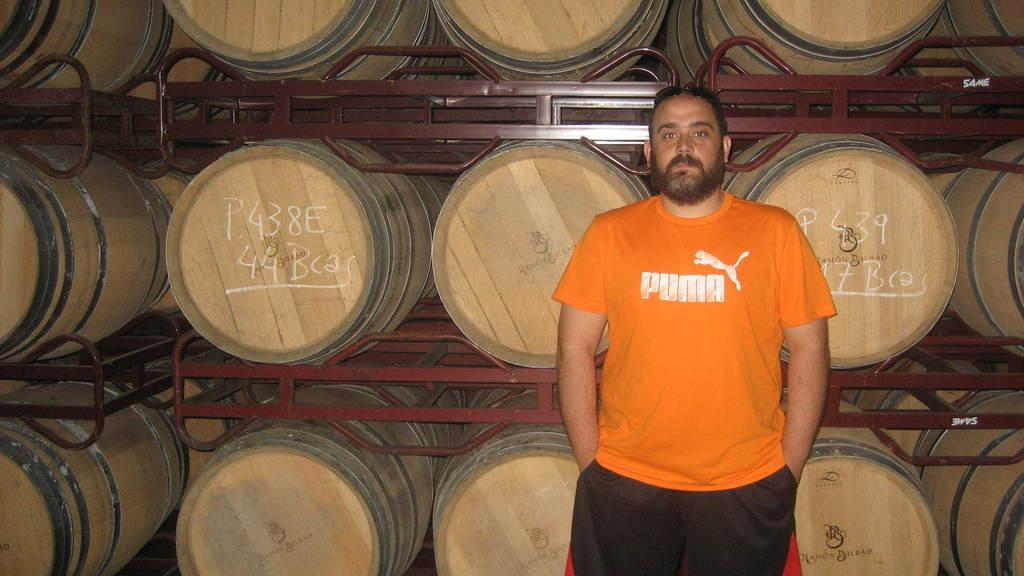What is the main subject of the image? There is a person standing in the center of the image. What can be seen in the background of the image? There are barrels in the background of the image. What color are the objects that are present in the image? The brown color objects are present in the image. Are there any words or letters visible on any objects in the image? Yes, there is text on some of the barrels. How does the wind affect the person standing in the image? There is no mention of wind in the image, so we cannot determine its effect on the person. Can you tell me how many toads are present in the image? There are no toads present in the image. 